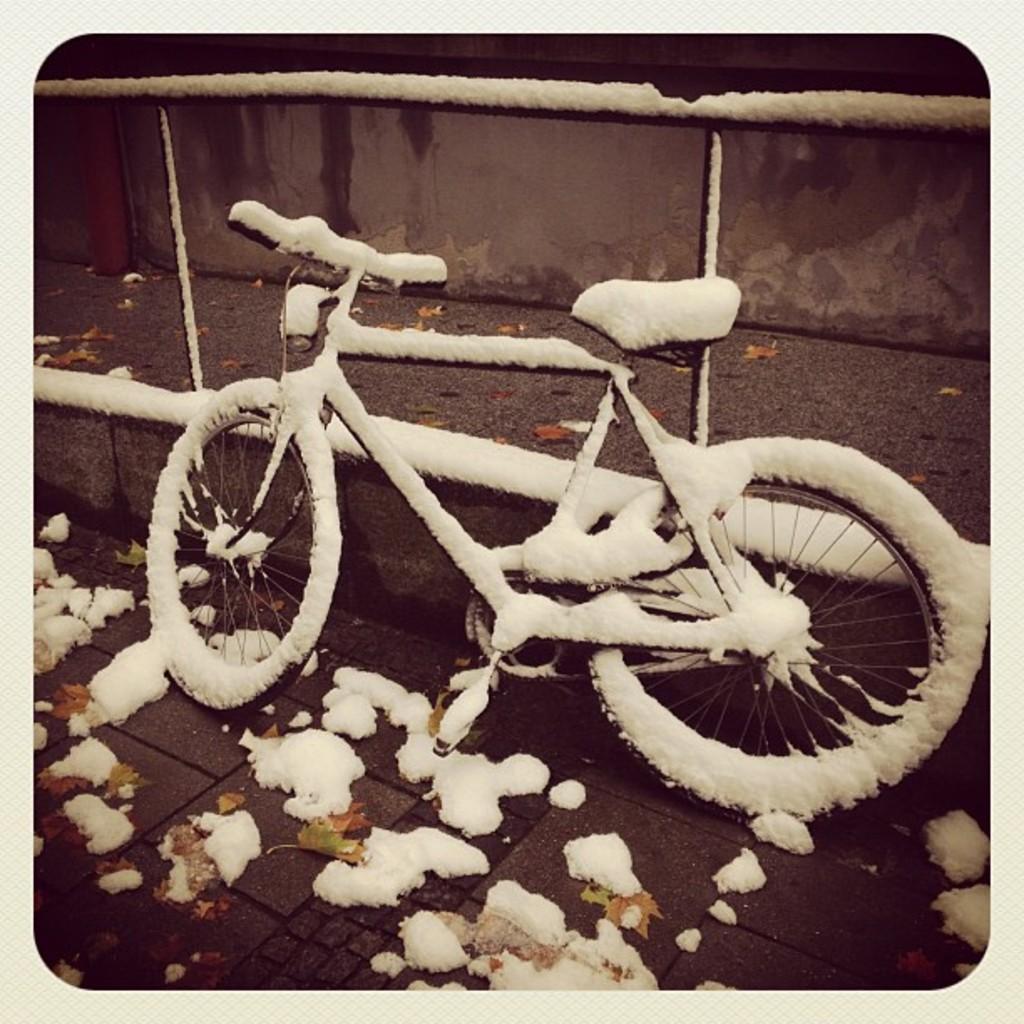In one or two sentences, can you explain what this image depicts? In this image I can see a bicycle covered with snow. Background the wall is in brown and black color. 